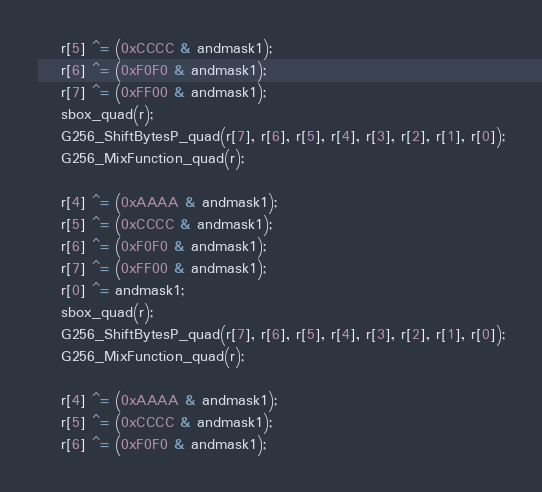<code> <loc_0><loc_0><loc_500><loc_500><_Cuda_>	r[5] ^= (0xCCCC & andmask1);
	r[6] ^= (0xF0F0 & andmask1);
	r[7] ^= (0xFF00 & andmask1);
	sbox_quad(r);
	G256_ShiftBytesP_quad(r[7], r[6], r[5], r[4], r[3], r[2], r[1], r[0]);
	G256_MixFunction_quad(r);

	r[4] ^= (0xAAAA & andmask1);
	r[5] ^= (0xCCCC & andmask1);
	r[6] ^= (0xF0F0 & andmask1);
	r[7] ^= (0xFF00 & andmask1);
	r[0] ^= andmask1;
	sbox_quad(r);
	G256_ShiftBytesP_quad(r[7], r[6], r[5], r[4], r[3], r[2], r[1], r[0]);
	G256_MixFunction_quad(r);

	r[4] ^= (0xAAAA & andmask1);
	r[5] ^= (0xCCCC & andmask1);
	r[6] ^= (0xF0F0 & andmask1);</code> 